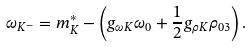Convert formula to latex. <formula><loc_0><loc_0><loc_500><loc_500>\omega _ { K ^ { - } } = m _ { K } ^ { * } - \left ( g _ { \omega K } \omega _ { 0 } + \frac { 1 } { 2 } g _ { \rho K } \rho _ { 0 3 } \right ) .</formula> 